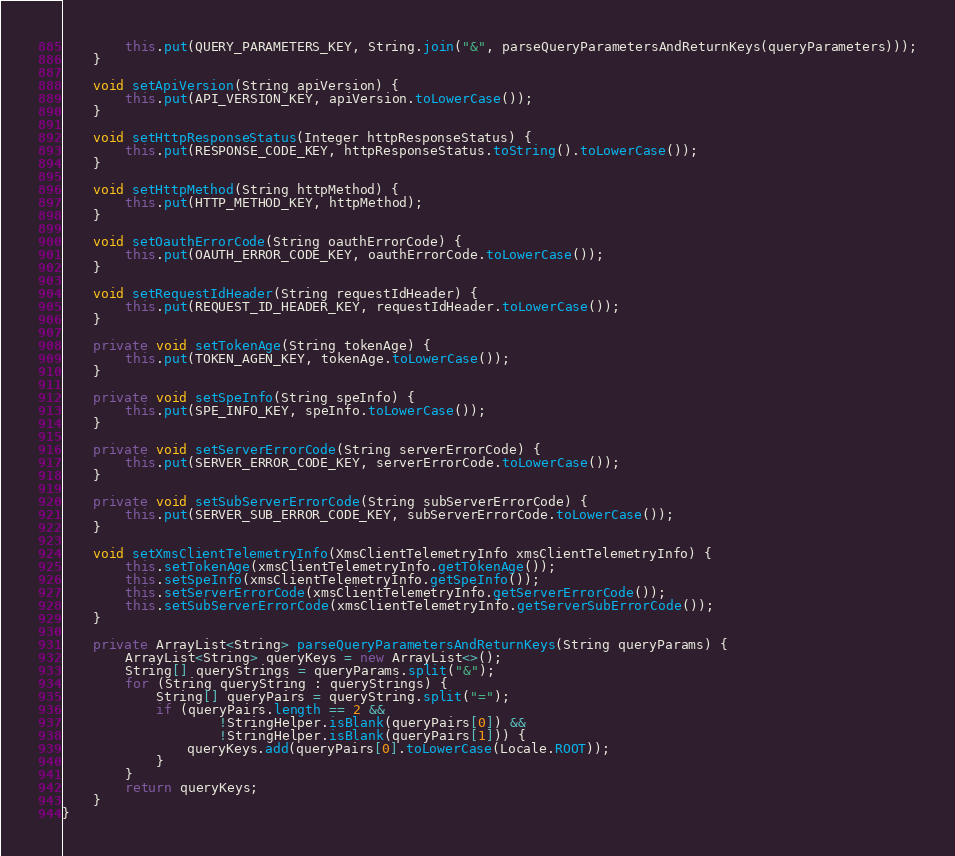<code> <loc_0><loc_0><loc_500><loc_500><_Java_>        this.put(QUERY_PARAMETERS_KEY, String.join("&", parseQueryParametersAndReturnKeys(queryParameters)));
    }

    void setApiVersion(String apiVersion) {
        this.put(API_VERSION_KEY, apiVersion.toLowerCase());
    }

    void setHttpResponseStatus(Integer httpResponseStatus) {
        this.put(RESPONSE_CODE_KEY, httpResponseStatus.toString().toLowerCase());
    }

    void setHttpMethod(String httpMethod) {
        this.put(HTTP_METHOD_KEY, httpMethod);
    }

    void setOauthErrorCode(String oauthErrorCode) {
        this.put(OAUTH_ERROR_CODE_KEY, oauthErrorCode.toLowerCase());
    }

    void setRequestIdHeader(String requestIdHeader) {
        this.put(REQUEST_ID_HEADER_KEY, requestIdHeader.toLowerCase());
    }

    private void setTokenAge(String tokenAge) {
        this.put(TOKEN_AGEN_KEY, tokenAge.toLowerCase());
    }

    private void setSpeInfo(String speInfo) {
        this.put(SPE_INFO_KEY, speInfo.toLowerCase());
    }

    private void setServerErrorCode(String serverErrorCode) {
        this.put(SERVER_ERROR_CODE_KEY, serverErrorCode.toLowerCase());
    }

    private void setSubServerErrorCode(String subServerErrorCode) {
        this.put(SERVER_SUB_ERROR_CODE_KEY, subServerErrorCode.toLowerCase());
    }

    void setXmsClientTelemetryInfo(XmsClientTelemetryInfo xmsClientTelemetryInfo) {
        this.setTokenAge(xmsClientTelemetryInfo.getTokenAge());
        this.setSpeInfo(xmsClientTelemetryInfo.getSpeInfo());
        this.setServerErrorCode(xmsClientTelemetryInfo.getServerErrorCode());
        this.setSubServerErrorCode(xmsClientTelemetryInfo.getServerSubErrorCode());
    }

    private ArrayList<String> parseQueryParametersAndReturnKeys(String queryParams) {
        ArrayList<String> queryKeys = new ArrayList<>();
        String[] queryStrings = queryParams.split("&");
        for (String queryString : queryStrings) {
            String[] queryPairs = queryString.split("=");
            if (queryPairs.length == 2 &&
                    !StringHelper.isBlank(queryPairs[0]) &&
                    !StringHelper.isBlank(queryPairs[1])) {
                queryKeys.add(queryPairs[0].toLowerCase(Locale.ROOT));
            }
        }
        return queryKeys;
    }
}
</code> 